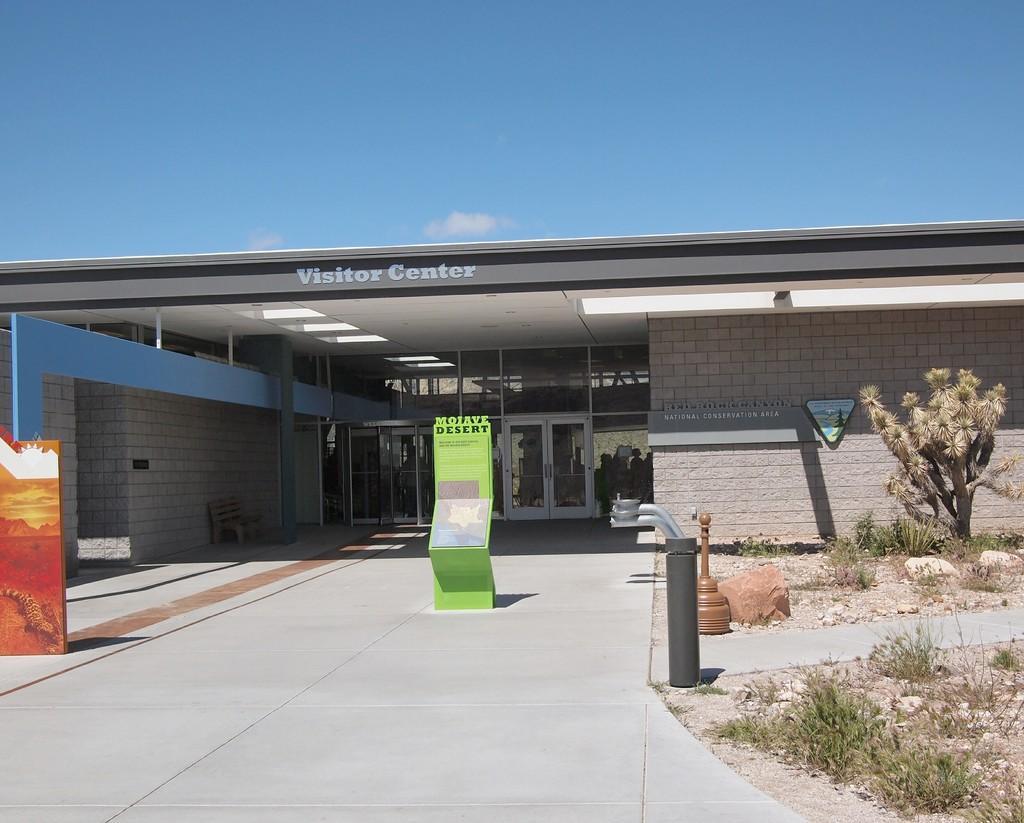Could you give a brief overview of what you see in this image? This image consists of a building. In the front, there is a board along with the doors. At the bottom, there is a road. To the right, there are plants along with the rocks. At the top, there is a sky in blue color. 